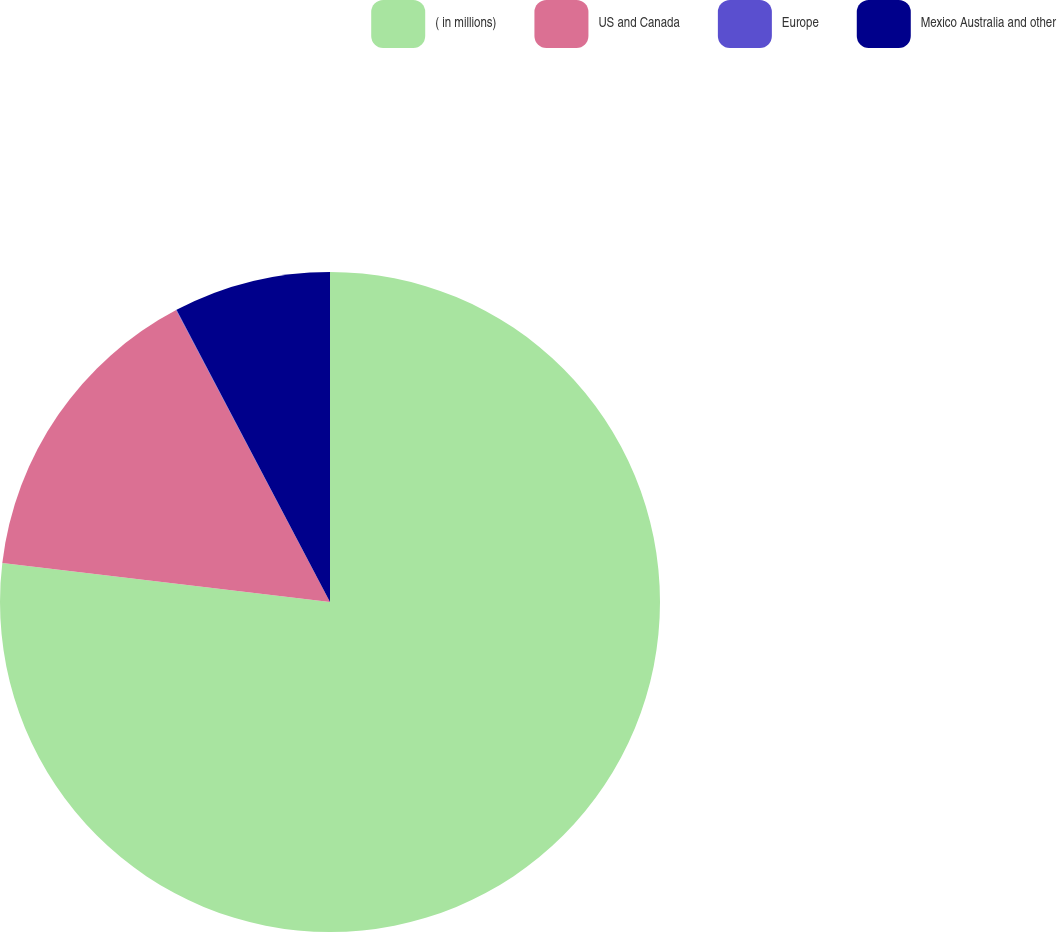<chart> <loc_0><loc_0><loc_500><loc_500><pie_chart><fcel>( in millions)<fcel>US and Canada<fcel>Europe<fcel>Mexico Australia and other<nl><fcel>76.89%<fcel>15.39%<fcel>0.02%<fcel>7.7%<nl></chart> 